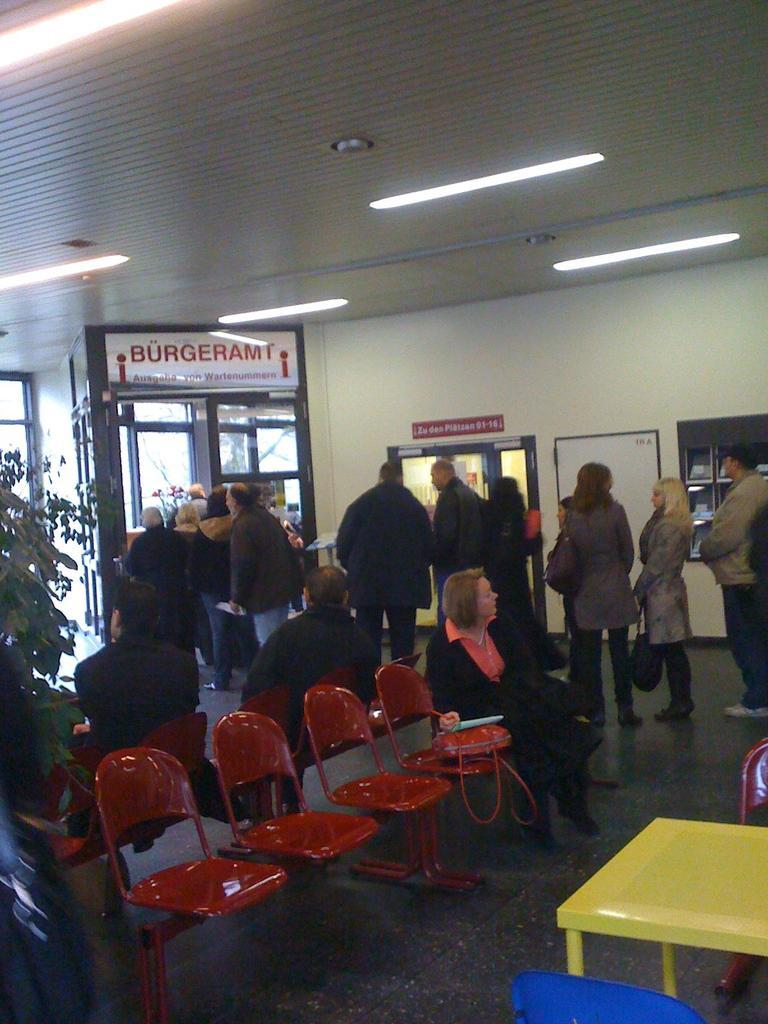In one or two sentences, can you explain what this image depicts? In this image there are group of people standing on the floor at the left side of the image there is a plant and at the top of the image there is a roof with lights. 